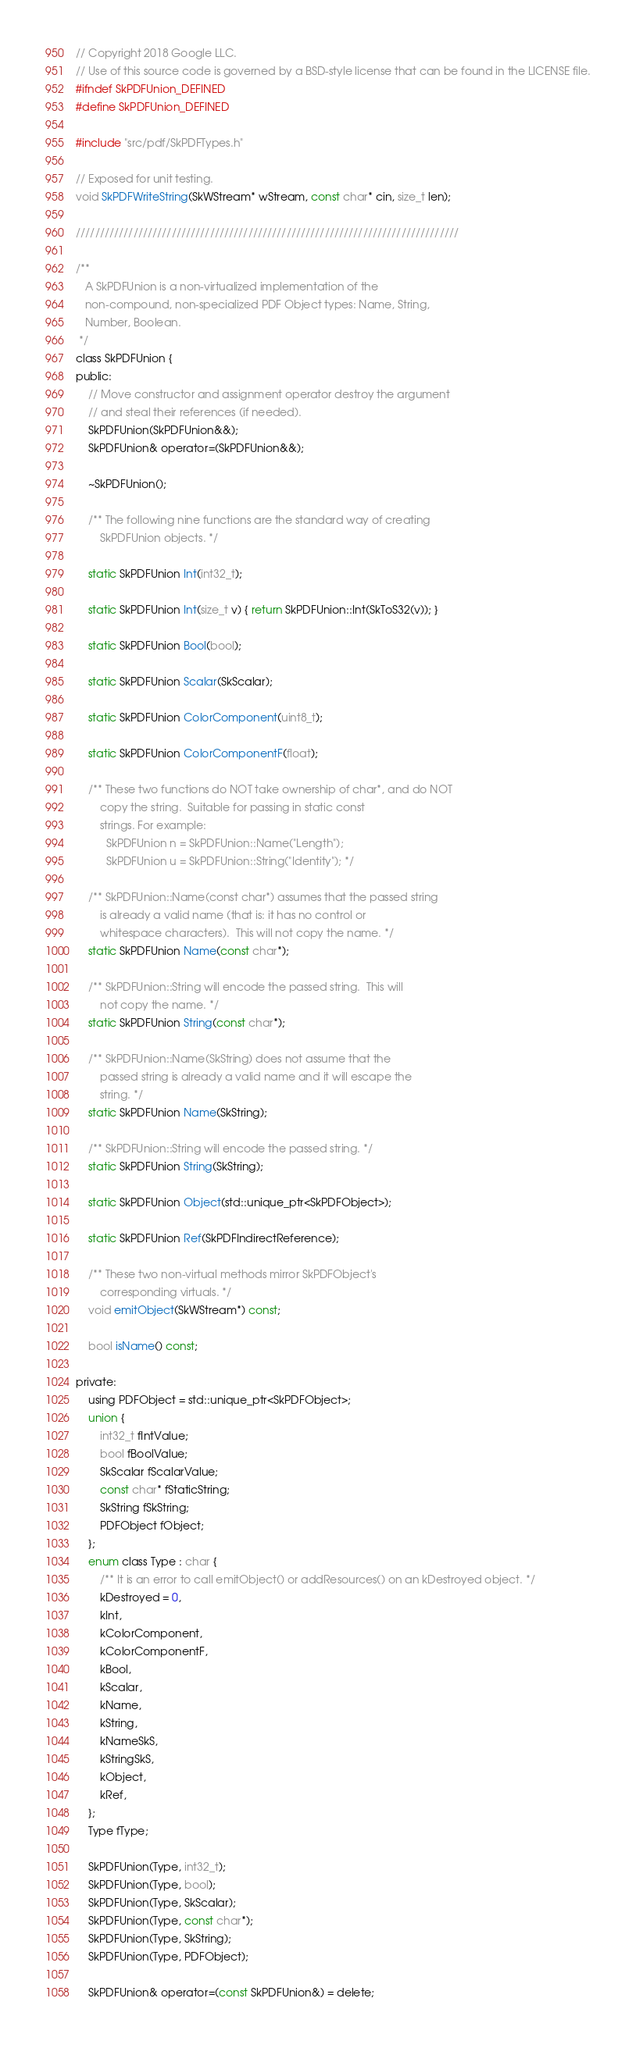Convert code to text. <code><loc_0><loc_0><loc_500><loc_500><_C_>// Copyright 2018 Google LLC.
// Use of this source code is governed by a BSD-style license that can be found in the LICENSE file.
#ifndef SkPDFUnion_DEFINED
#define SkPDFUnion_DEFINED

#include "src/pdf/SkPDFTypes.h"

// Exposed for unit testing.
void SkPDFWriteString(SkWStream* wStream, const char* cin, size_t len);

////////////////////////////////////////////////////////////////////////////////

/**
   A SkPDFUnion is a non-virtualized implementation of the
   non-compound, non-specialized PDF Object types: Name, String,
   Number, Boolean.
 */
class SkPDFUnion {
public:
    // Move constructor and assignment operator destroy the argument
    // and steal their references (if needed).
    SkPDFUnion(SkPDFUnion&&);
    SkPDFUnion& operator=(SkPDFUnion&&);

    ~SkPDFUnion();

    /** The following nine functions are the standard way of creating
        SkPDFUnion objects. */

    static SkPDFUnion Int(int32_t);

    static SkPDFUnion Int(size_t v) { return SkPDFUnion::Int(SkToS32(v)); }

    static SkPDFUnion Bool(bool);

    static SkPDFUnion Scalar(SkScalar);

    static SkPDFUnion ColorComponent(uint8_t);

    static SkPDFUnion ColorComponentF(float);

    /** These two functions do NOT take ownership of char*, and do NOT
        copy the string.  Suitable for passing in static const
        strings. For example:
          SkPDFUnion n = SkPDFUnion::Name("Length");
          SkPDFUnion u = SkPDFUnion::String("Identity"); */

    /** SkPDFUnion::Name(const char*) assumes that the passed string
        is already a valid name (that is: it has no control or
        whitespace characters).  This will not copy the name. */
    static SkPDFUnion Name(const char*);

    /** SkPDFUnion::String will encode the passed string.  This will
        not copy the name. */
    static SkPDFUnion String(const char*);

    /** SkPDFUnion::Name(SkString) does not assume that the
        passed string is already a valid name and it will escape the
        string. */
    static SkPDFUnion Name(SkString);

    /** SkPDFUnion::String will encode the passed string. */
    static SkPDFUnion String(SkString);

    static SkPDFUnion Object(std::unique_ptr<SkPDFObject>);

    static SkPDFUnion Ref(SkPDFIndirectReference);

    /** These two non-virtual methods mirror SkPDFObject's
        corresponding virtuals. */
    void emitObject(SkWStream*) const;

    bool isName() const;

private:
    using PDFObject = std::unique_ptr<SkPDFObject>;
    union {
        int32_t fIntValue;
        bool fBoolValue;
        SkScalar fScalarValue;
        const char* fStaticString;
        SkString fSkString;
        PDFObject fObject;
    };
    enum class Type : char {
        /** It is an error to call emitObject() or addResources() on an kDestroyed object. */
        kDestroyed = 0,
        kInt,
        kColorComponent,
        kColorComponentF,
        kBool,
        kScalar,
        kName,
        kString,
        kNameSkS,
        kStringSkS,
        kObject,
        kRef,
    };
    Type fType;

    SkPDFUnion(Type, int32_t);
    SkPDFUnion(Type, bool);
    SkPDFUnion(Type, SkScalar);
    SkPDFUnion(Type, const char*);
    SkPDFUnion(Type, SkString);
    SkPDFUnion(Type, PDFObject);

    SkPDFUnion& operator=(const SkPDFUnion&) = delete;</code> 